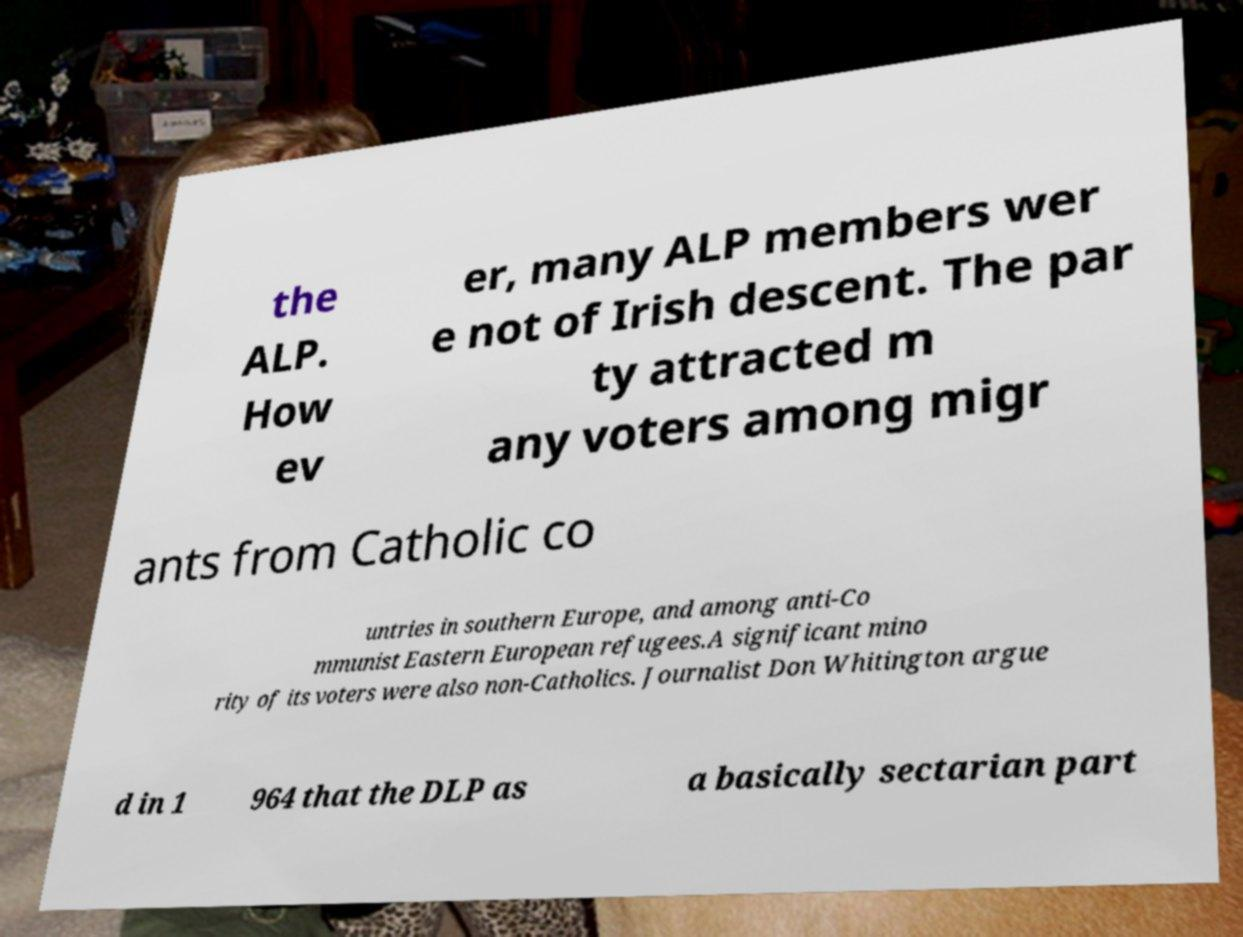Could you extract and type out the text from this image? the ALP. How ev er, many ALP members wer e not of Irish descent. The par ty attracted m any voters among migr ants from Catholic co untries in southern Europe, and among anti-Co mmunist Eastern European refugees.A significant mino rity of its voters were also non-Catholics. Journalist Don Whitington argue d in 1 964 that the DLP as a basically sectarian part 